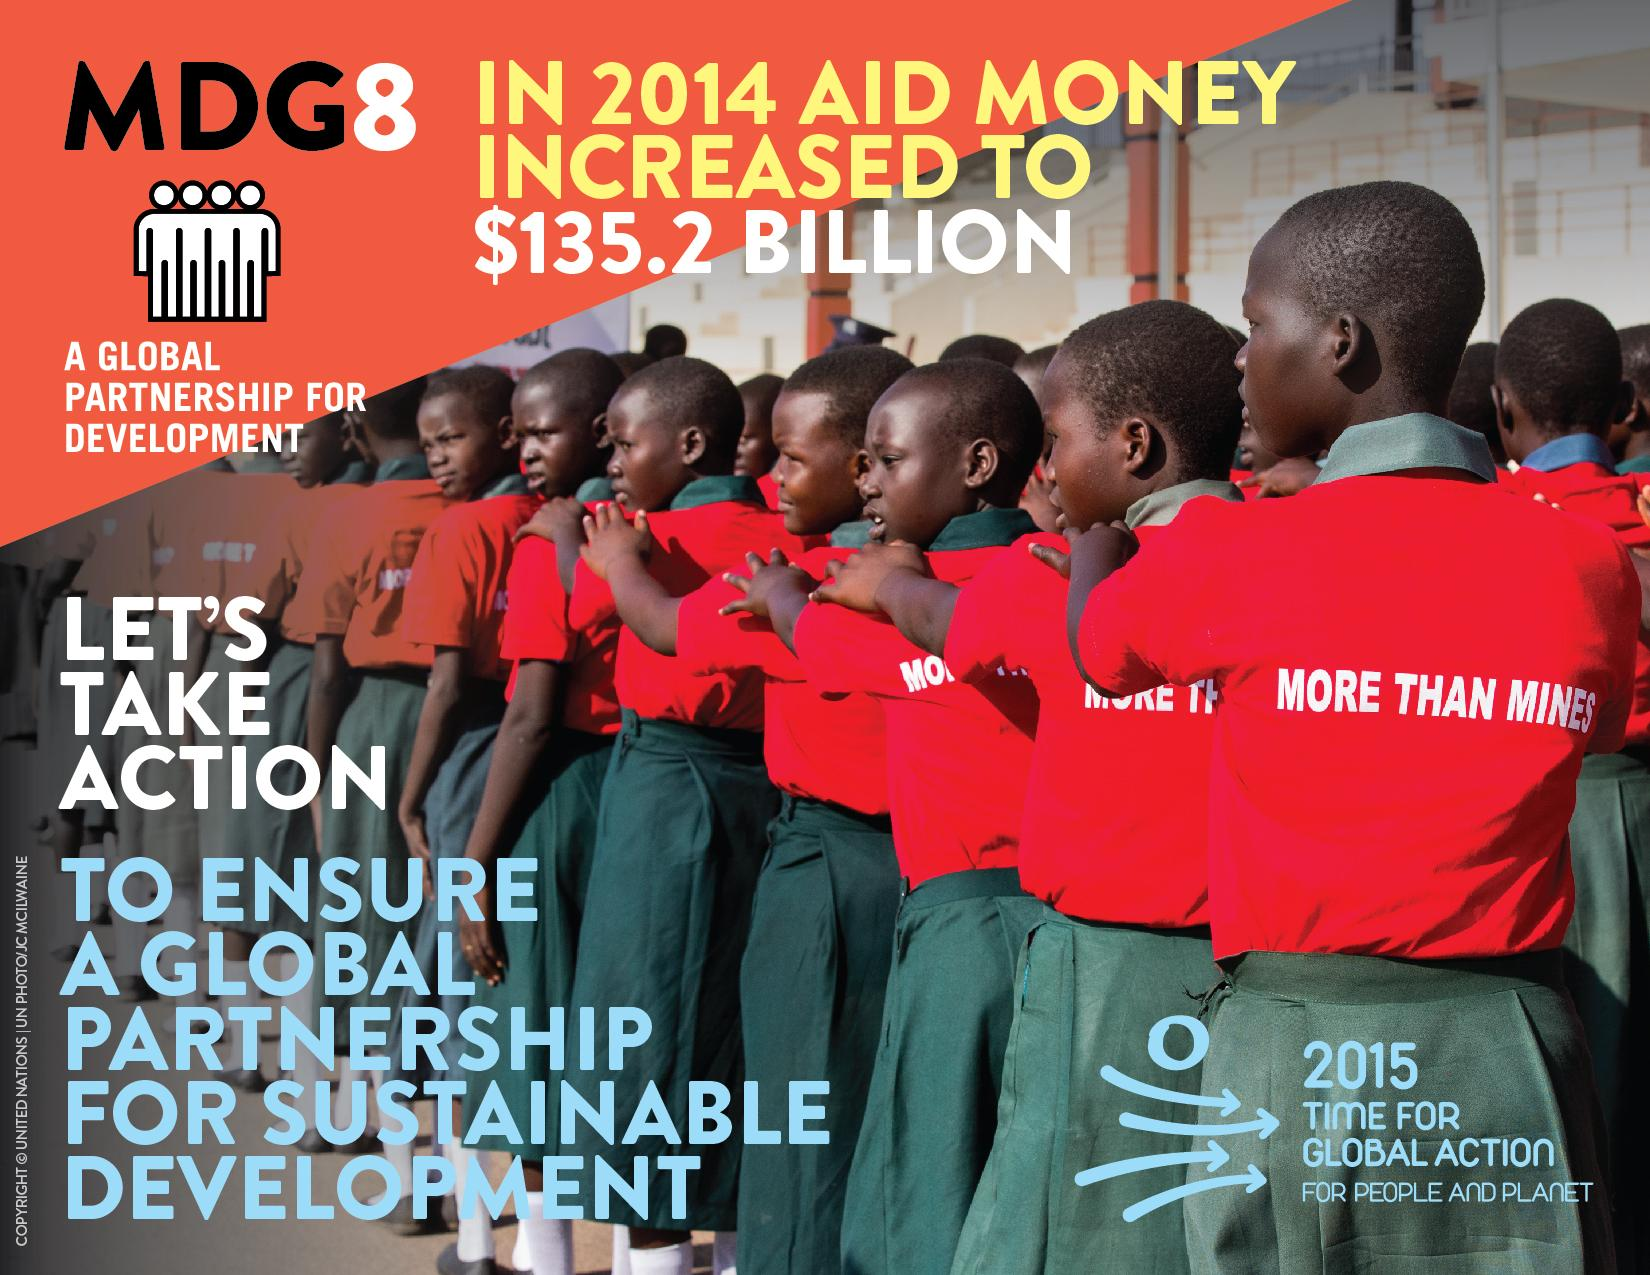Give some essential details in this illustration. The message on the T-shirts of the children is, "We are more than just mines. 